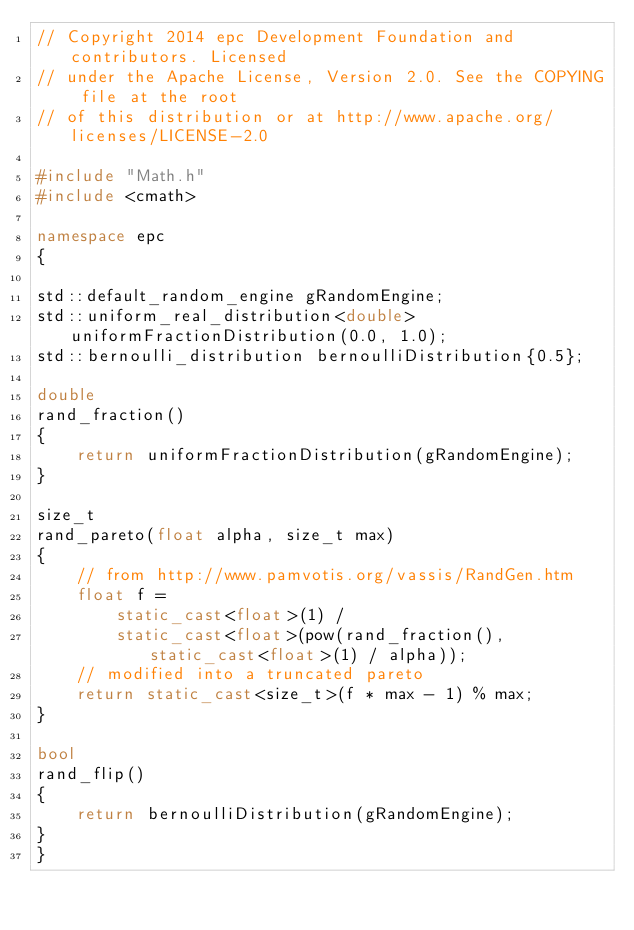<code> <loc_0><loc_0><loc_500><loc_500><_C++_>// Copyright 2014 epc Development Foundation and contributors. Licensed
// under the Apache License, Version 2.0. See the COPYING file at the root
// of this distribution or at http://www.apache.org/licenses/LICENSE-2.0

#include "Math.h"
#include <cmath>

namespace epc
{

std::default_random_engine gRandomEngine;
std::uniform_real_distribution<double> uniformFractionDistribution(0.0, 1.0);
std::bernoulli_distribution bernoulliDistribution{0.5};

double
rand_fraction()
{
    return uniformFractionDistribution(gRandomEngine);
}

size_t
rand_pareto(float alpha, size_t max)
{
    // from http://www.pamvotis.org/vassis/RandGen.htm
    float f =
        static_cast<float>(1) /
        static_cast<float>(pow(rand_fraction(), static_cast<float>(1) / alpha));
    // modified into a truncated pareto
    return static_cast<size_t>(f * max - 1) % max;
}

bool
rand_flip()
{
    return bernoulliDistribution(gRandomEngine);
}
}
</code> 